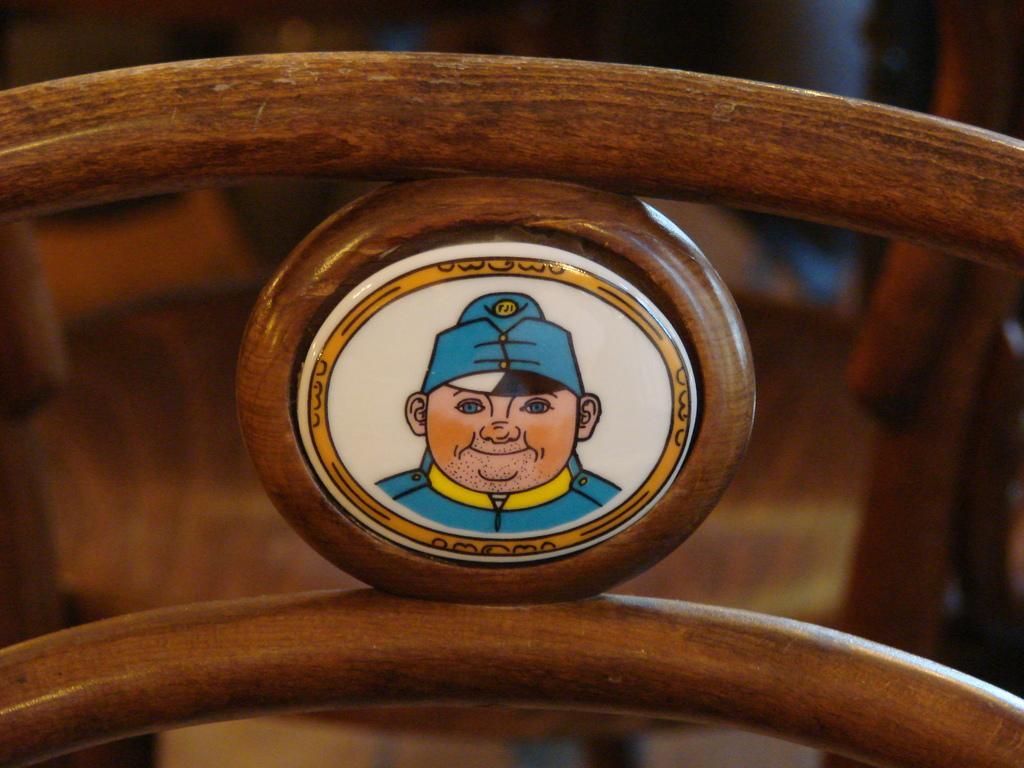Can you describe this image briefly? Image is on the wooden ring. Those are wooden objects. In the background of the image it is blurry. 